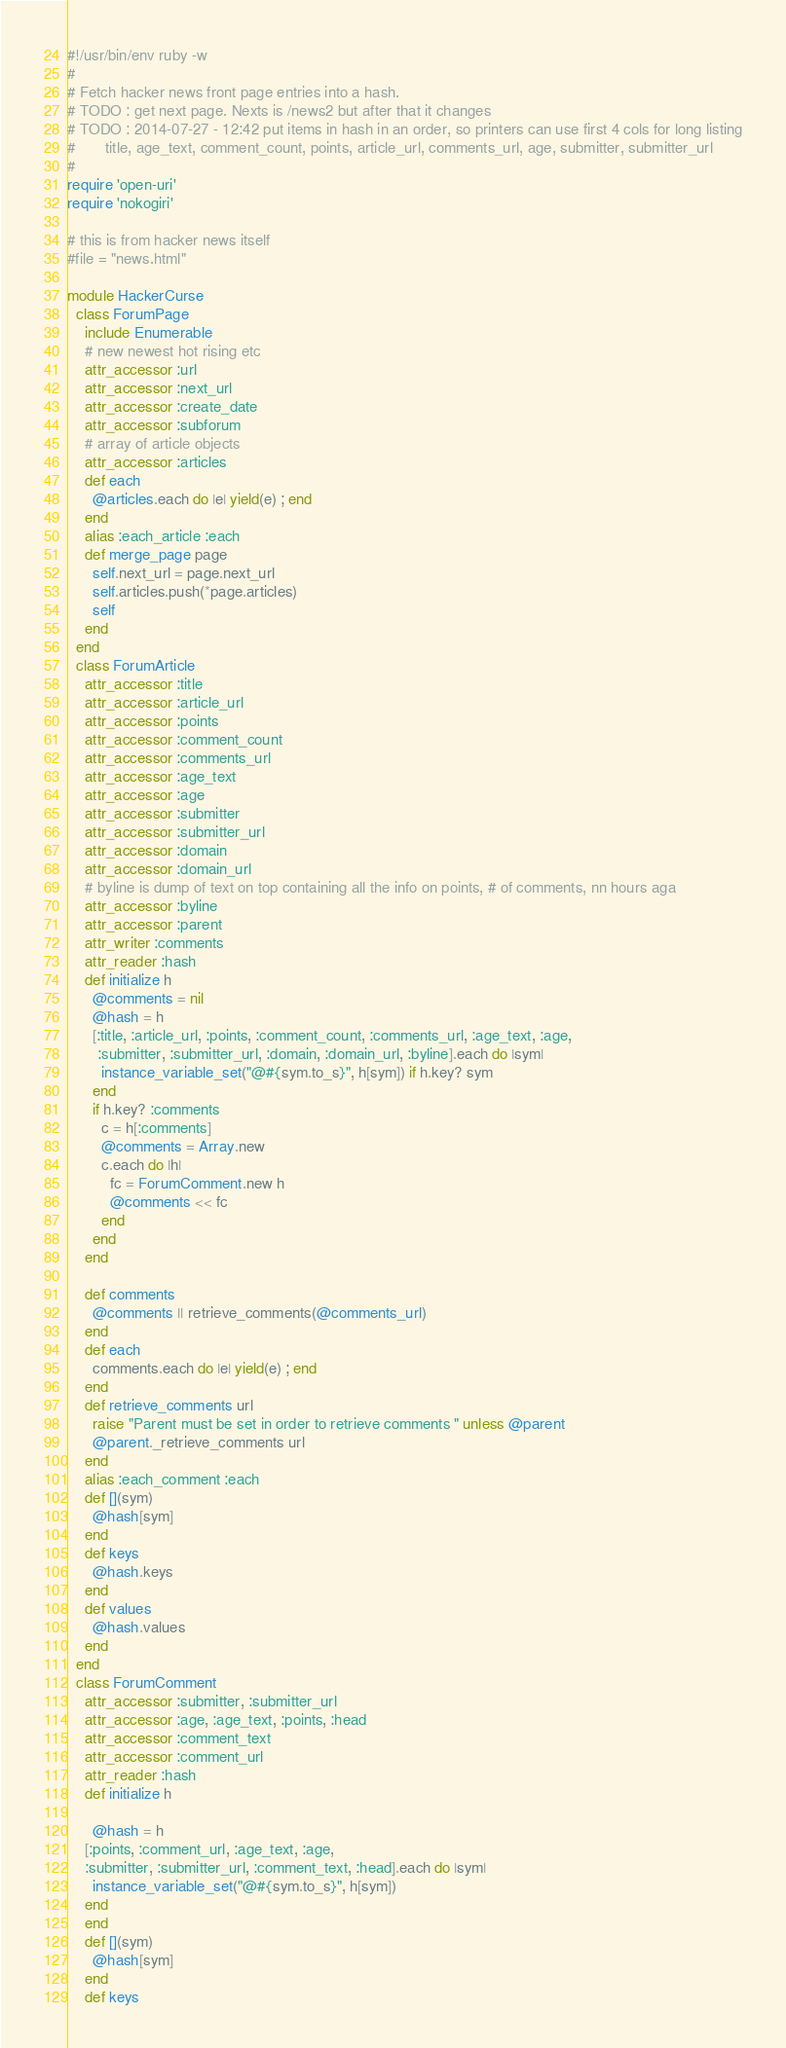<code> <loc_0><loc_0><loc_500><loc_500><_Ruby_>#!/usr/bin/env ruby -w
#
# Fetch hacker news front page entries into a hash.
# TODO : get next page. Nexts is /news2 but after that it changes
# TODO : 2014-07-27 - 12:42 put items in hash in an order, so printers can use first 4 cols for long listing
#       title, age_text, comment_count, points, article_url, comments_url, age, submitter, submitter_url
#
require 'open-uri'
require 'nokogiri'

# this is from hacker news itself
#file = "news.html"

module HackerCurse
  class ForumPage
    include Enumerable
    # new newest hot rising etc
    attr_accessor :url
    attr_accessor :next_url
    attr_accessor :create_date
    attr_accessor :subforum
    # array of article objects
    attr_accessor :articles
    def each
      @articles.each do |e| yield(e) ; end
    end 
    alias :each_article :each
    def merge_page page
      self.next_url = page.next_url
      self.articles.push(*page.articles)
      self
    end
  end
  class ForumArticle
    attr_accessor :title
    attr_accessor :article_url
    attr_accessor :points
    attr_accessor :comment_count
    attr_accessor :comments_url
    attr_accessor :age_text
    attr_accessor :age
    attr_accessor :submitter
    attr_accessor :submitter_url
    attr_accessor :domain
    attr_accessor :domain_url
    # byline is dump of text on top containing all the info on points, # of comments, nn hours aga
    attr_accessor :byline
    attr_accessor :parent
    attr_writer :comments
    attr_reader :hash
    def initialize h
      @comments = nil
      @hash = h
      [:title, :article_url, :points, :comment_count, :comments_url, :age_text, :age,
       :submitter, :submitter_url, :domain, :domain_url, :byline].each do |sym|
        instance_variable_set("@#{sym.to_s}", h[sym]) if h.key? sym
      end
      if h.key? :comments
        c = h[:comments]
        @comments = Array.new
        c.each do |h|
          fc = ForumComment.new h
          @comments << fc
        end
      end
    end

    def comments
      @comments || retrieve_comments(@comments_url)
    end
    def each
      comments.each do |e| yield(e) ; end
    end 
    def retrieve_comments url
      raise "Parent must be set in order to retrieve comments " unless @parent
      @parent._retrieve_comments url
    end
    alias :each_comment :each
    def [](sym)
      @hash[sym]
    end
    def keys
      @hash.keys
    end
    def values
      @hash.values
    end
  end
  class ForumComment
    attr_accessor :submitter, :submitter_url
    attr_accessor :age, :age_text, :points, :head
    attr_accessor :comment_text
    attr_accessor :comment_url
    attr_reader :hash
    def initialize h

      @hash = h
    [:points, :comment_url, :age_text, :age,
    :submitter, :submitter_url, :comment_text, :head].each do |sym|
      instance_variable_set("@#{sym.to_s}", h[sym])
    end
    end
    def [](sym)
      @hash[sym]
    end
    def keys</code> 